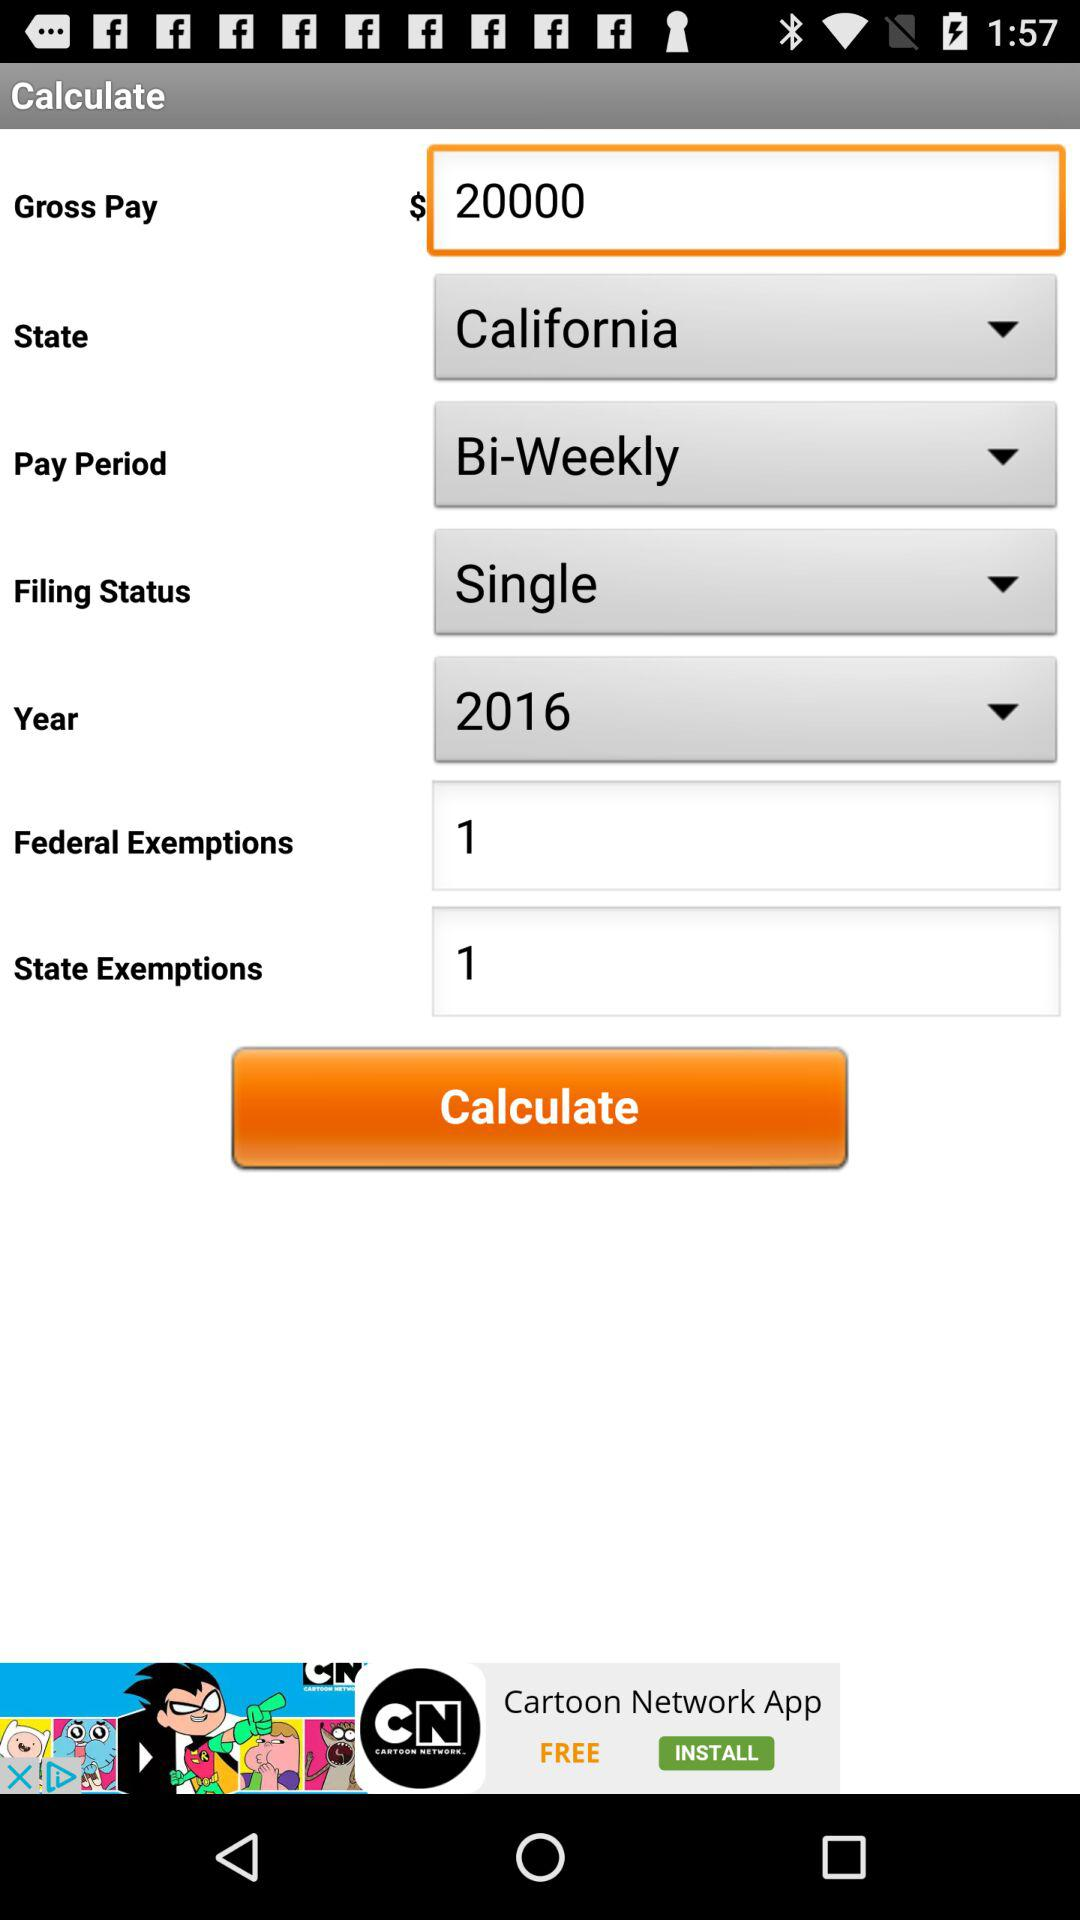What is the selected year? The selected year is 2016. 